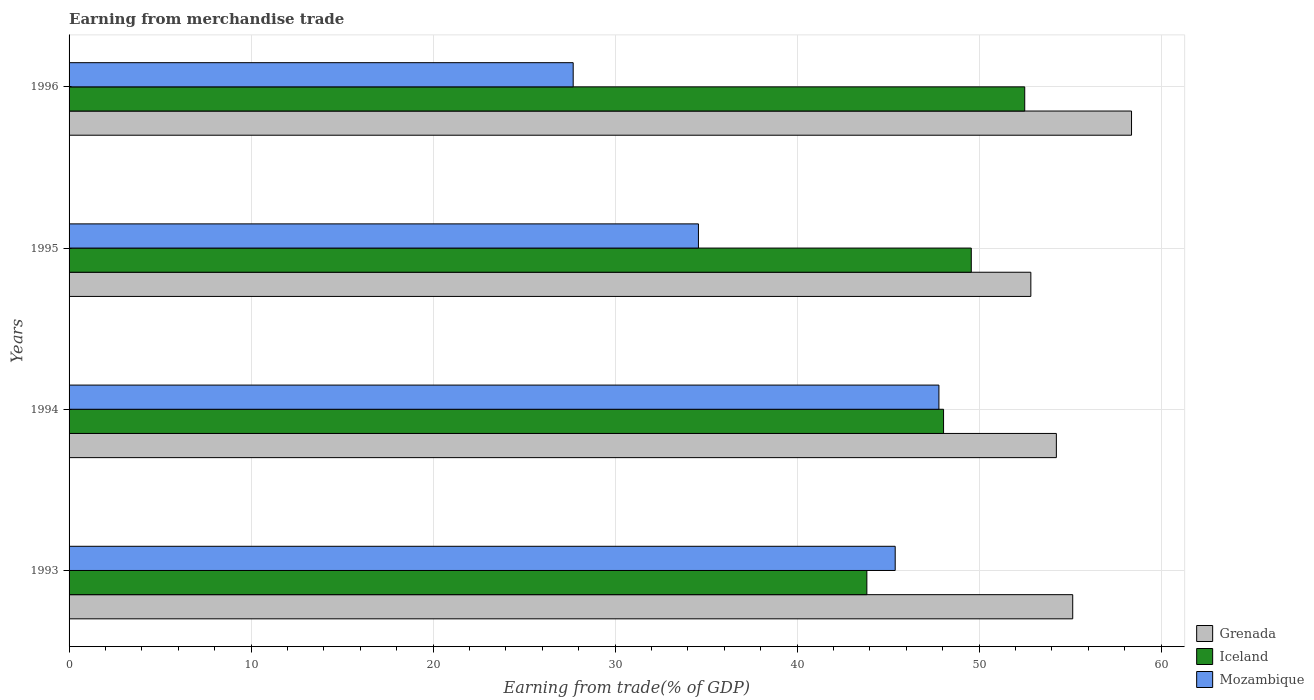How many bars are there on the 4th tick from the top?
Provide a succinct answer. 3. How many bars are there on the 4th tick from the bottom?
Make the answer very short. 3. What is the label of the 3rd group of bars from the top?
Keep it short and to the point. 1994. What is the earnings from trade in Grenada in 1995?
Your response must be concise. 52.84. Across all years, what is the maximum earnings from trade in Iceland?
Your response must be concise. 52.51. Across all years, what is the minimum earnings from trade in Grenada?
Keep it short and to the point. 52.84. In which year was the earnings from trade in Iceland minimum?
Make the answer very short. 1993. What is the total earnings from trade in Iceland in the graph?
Ensure brevity in your answer.  193.96. What is the difference between the earnings from trade in Mozambique in 1993 and that in 1996?
Your answer should be very brief. 17.69. What is the difference between the earnings from trade in Mozambique in 1994 and the earnings from trade in Iceland in 1995?
Your answer should be very brief. -1.78. What is the average earnings from trade in Iceland per year?
Keep it short and to the point. 48.49. In the year 1995, what is the difference between the earnings from trade in Iceland and earnings from trade in Grenada?
Provide a succinct answer. -3.27. What is the ratio of the earnings from trade in Mozambique in 1994 to that in 1995?
Make the answer very short. 1.38. Is the earnings from trade in Grenada in 1993 less than that in 1996?
Ensure brevity in your answer.  Yes. What is the difference between the highest and the second highest earnings from trade in Mozambique?
Keep it short and to the point. 2.4. What is the difference between the highest and the lowest earnings from trade in Iceland?
Offer a very short reply. 8.67. In how many years, is the earnings from trade in Grenada greater than the average earnings from trade in Grenada taken over all years?
Provide a short and direct response. 1. Is the sum of the earnings from trade in Mozambique in 1993 and 1996 greater than the maximum earnings from trade in Iceland across all years?
Ensure brevity in your answer.  Yes. What does the 3rd bar from the top in 1995 represents?
Ensure brevity in your answer.  Grenada. What does the 3rd bar from the bottom in 1996 represents?
Offer a terse response. Mozambique. Is it the case that in every year, the sum of the earnings from trade in Grenada and earnings from trade in Mozambique is greater than the earnings from trade in Iceland?
Provide a succinct answer. Yes. Are all the bars in the graph horizontal?
Ensure brevity in your answer.  Yes. What is the difference between two consecutive major ticks on the X-axis?
Offer a terse response. 10. Are the values on the major ticks of X-axis written in scientific E-notation?
Offer a very short reply. No. Where does the legend appear in the graph?
Your answer should be compact. Bottom right. How are the legend labels stacked?
Provide a short and direct response. Vertical. What is the title of the graph?
Ensure brevity in your answer.  Earning from merchandise trade. What is the label or title of the X-axis?
Ensure brevity in your answer.  Earning from trade(% of GDP). What is the Earning from trade(% of GDP) of Grenada in 1993?
Your response must be concise. 55.14. What is the Earning from trade(% of GDP) in Iceland in 1993?
Your answer should be very brief. 43.83. What is the Earning from trade(% of GDP) in Mozambique in 1993?
Your answer should be compact. 45.39. What is the Earning from trade(% of GDP) of Grenada in 1994?
Provide a succinct answer. 54.24. What is the Earning from trade(% of GDP) of Iceland in 1994?
Offer a very short reply. 48.05. What is the Earning from trade(% of GDP) of Mozambique in 1994?
Offer a terse response. 47.79. What is the Earning from trade(% of GDP) of Grenada in 1995?
Provide a short and direct response. 52.84. What is the Earning from trade(% of GDP) of Iceland in 1995?
Make the answer very short. 49.57. What is the Earning from trade(% of GDP) of Mozambique in 1995?
Make the answer very short. 34.58. What is the Earning from trade(% of GDP) in Grenada in 1996?
Keep it short and to the point. 58.37. What is the Earning from trade(% of GDP) in Iceland in 1996?
Offer a terse response. 52.51. What is the Earning from trade(% of GDP) in Mozambique in 1996?
Your answer should be very brief. 27.7. Across all years, what is the maximum Earning from trade(% of GDP) of Grenada?
Keep it short and to the point. 58.37. Across all years, what is the maximum Earning from trade(% of GDP) in Iceland?
Offer a very short reply. 52.51. Across all years, what is the maximum Earning from trade(% of GDP) in Mozambique?
Offer a very short reply. 47.79. Across all years, what is the minimum Earning from trade(% of GDP) of Grenada?
Provide a short and direct response. 52.84. Across all years, what is the minimum Earning from trade(% of GDP) in Iceland?
Provide a succinct answer. 43.83. Across all years, what is the minimum Earning from trade(% of GDP) of Mozambique?
Offer a very short reply. 27.7. What is the total Earning from trade(% of GDP) in Grenada in the graph?
Provide a succinct answer. 220.6. What is the total Earning from trade(% of GDP) of Iceland in the graph?
Your response must be concise. 193.96. What is the total Earning from trade(% of GDP) in Mozambique in the graph?
Make the answer very short. 155.46. What is the difference between the Earning from trade(% of GDP) in Grenada in 1993 and that in 1994?
Offer a very short reply. 0.9. What is the difference between the Earning from trade(% of GDP) of Iceland in 1993 and that in 1994?
Provide a short and direct response. -4.21. What is the difference between the Earning from trade(% of GDP) of Mozambique in 1993 and that in 1994?
Your answer should be compact. -2.4. What is the difference between the Earning from trade(% of GDP) in Grenada in 1993 and that in 1995?
Ensure brevity in your answer.  2.3. What is the difference between the Earning from trade(% of GDP) of Iceland in 1993 and that in 1995?
Provide a succinct answer. -5.74. What is the difference between the Earning from trade(% of GDP) of Mozambique in 1993 and that in 1995?
Ensure brevity in your answer.  10.81. What is the difference between the Earning from trade(% of GDP) of Grenada in 1993 and that in 1996?
Your answer should be very brief. -3.23. What is the difference between the Earning from trade(% of GDP) in Iceland in 1993 and that in 1996?
Give a very brief answer. -8.67. What is the difference between the Earning from trade(% of GDP) in Mozambique in 1993 and that in 1996?
Make the answer very short. 17.69. What is the difference between the Earning from trade(% of GDP) in Grenada in 1994 and that in 1995?
Provide a succinct answer. 1.4. What is the difference between the Earning from trade(% of GDP) in Iceland in 1994 and that in 1995?
Offer a very short reply. -1.52. What is the difference between the Earning from trade(% of GDP) in Mozambique in 1994 and that in 1995?
Offer a very short reply. 13.21. What is the difference between the Earning from trade(% of GDP) of Grenada in 1994 and that in 1996?
Your response must be concise. -4.13. What is the difference between the Earning from trade(% of GDP) in Iceland in 1994 and that in 1996?
Your response must be concise. -4.46. What is the difference between the Earning from trade(% of GDP) in Mozambique in 1994 and that in 1996?
Keep it short and to the point. 20.09. What is the difference between the Earning from trade(% of GDP) of Grenada in 1995 and that in 1996?
Offer a very short reply. -5.53. What is the difference between the Earning from trade(% of GDP) in Iceland in 1995 and that in 1996?
Keep it short and to the point. -2.94. What is the difference between the Earning from trade(% of GDP) of Mozambique in 1995 and that in 1996?
Ensure brevity in your answer.  6.88. What is the difference between the Earning from trade(% of GDP) of Grenada in 1993 and the Earning from trade(% of GDP) of Iceland in 1994?
Ensure brevity in your answer.  7.1. What is the difference between the Earning from trade(% of GDP) of Grenada in 1993 and the Earning from trade(% of GDP) of Mozambique in 1994?
Ensure brevity in your answer.  7.35. What is the difference between the Earning from trade(% of GDP) in Iceland in 1993 and the Earning from trade(% of GDP) in Mozambique in 1994?
Your answer should be very brief. -3.96. What is the difference between the Earning from trade(% of GDP) in Grenada in 1993 and the Earning from trade(% of GDP) in Iceland in 1995?
Your answer should be compact. 5.57. What is the difference between the Earning from trade(% of GDP) of Grenada in 1993 and the Earning from trade(% of GDP) of Mozambique in 1995?
Ensure brevity in your answer.  20.56. What is the difference between the Earning from trade(% of GDP) of Iceland in 1993 and the Earning from trade(% of GDP) of Mozambique in 1995?
Provide a short and direct response. 9.25. What is the difference between the Earning from trade(% of GDP) in Grenada in 1993 and the Earning from trade(% of GDP) in Iceland in 1996?
Provide a short and direct response. 2.64. What is the difference between the Earning from trade(% of GDP) in Grenada in 1993 and the Earning from trade(% of GDP) in Mozambique in 1996?
Make the answer very short. 27.45. What is the difference between the Earning from trade(% of GDP) of Iceland in 1993 and the Earning from trade(% of GDP) of Mozambique in 1996?
Offer a terse response. 16.14. What is the difference between the Earning from trade(% of GDP) of Grenada in 1994 and the Earning from trade(% of GDP) of Iceland in 1995?
Ensure brevity in your answer.  4.67. What is the difference between the Earning from trade(% of GDP) of Grenada in 1994 and the Earning from trade(% of GDP) of Mozambique in 1995?
Offer a terse response. 19.67. What is the difference between the Earning from trade(% of GDP) in Iceland in 1994 and the Earning from trade(% of GDP) in Mozambique in 1995?
Your answer should be compact. 13.47. What is the difference between the Earning from trade(% of GDP) in Grenada in 1994 and the Earning from trade(% of GDP) in Iceland in 1996?
Provide a short and direct response. 1.74. What is the difference between the Earning from trade(% of GDP) in Grenada in 1994 and the Earning from trade(% of GDP) in Mozambique in 1996?
Keep it short and to the point. 26.55. What is the difference between the Earning from trade(% of GDP) in Iceland in 1994 and the Earning from trade(% of GDP) in Mozambique in 1996?
Your answer should be compact. 20.35. What is the difference between the Earning from trade(% of GDP) in Grenada in 1995 and the Earning from trade(% of GDP) in Iceland in 1996?
Offer a terse response. 0.34. What is the difference between the Earning from trade(% of GDP) in Grenada in 1995 and the Earning from trade(% of GDP) in Mozambique in 1996?
Provide a succinct answer. 25.14. What is the difference between the Earning from trade(% of GDP) of Iceland in 1995 and the Earning from trade(% of GDP) of Mozambique in 1996?
Offer a very short reply. 21.87. What is the average Earning from trade(% of GDP) in Grenada per year?
Offer a terse response. 55.15. What is the average Earning from trade(% of GDP) of Iceland per year?
Your answer should be very brief. 48.49. What is the average Earning from trade(% of GDP) of Mozambique per year?
Your answer should be compact. 38.86. In the year 1993, what is the difference between the Earning from trade(% of GDP) of Grenada and Earning from trade(% of GDP) of Iceland?
Offer a very short reply. 11.31. In the year 1993, what is the difference between the Earning from trade(% of GDP) in Grenada and Earning from trade(% of GDP) in Mozambique?
Make the answer very short. 9.75. In the year 1993, what is the difference between the Earning from trade(% of GDP) of Iceland and Earning from trade(% of GDP) of Mozambique?
Provide a short and direct response. -1.56. In the year 1994, what is the difference between the Earning from trade(% of GDP) in Grenada and Earning from trade(% of GDP) in Iceland?
Provide a succinct answer. 6.2. In the year 1994, what is the difference between the Earning from trade(% of GDP) of Grenada and Earning from trade(% of GDP) of Mozambique?
Your answer should be compact. 6.45. In the year 1994, what is the difference between the Earning from trade(% of GDP) of Iceland and Earning from trade(% of GDP) of Mozambique?
Your answer should be very brief. 0.26. In the year 1995, what is the difference between the Earning from trade(% of GDP) of Grenada and Earning from trade(% of GDP) of Iceland?
Keep it short and to the point. 3.27. In the year 1995, what is the difference between the Earning from trade(% of GDP) in Grenada and Earning from trade(% of GDP) in Mozambique?
Ensure brevity in your answer.  18.26. In the year 1995, what is the difference between the Earning from trade(% of GDP) in Iceland and Earning from trade(% of GDP) in Mozambique?
Ensure brevity in your answer.  14.99. In the year 1996, what is the difference between the Earning from trade(% of GDP) in Grenada and Earning from trade(% of GDP) in Iceland?
Make the answer very short. 5.87. In the year 1996, what is the difference between the Earning from trade(% of GDP) of Grenada and Earning from trade(% of GDP) of Mozambique?
Give a very brief answer. 30.68. In the year 1996, what is the difference between the Earning from trade(% of GDP) of Iceland and Earning from trade(% of GDP) of Mozambique?
Ensure brevity in your answer.  24.81. What is the ratio of the Earning from trade(% of GDP) in Grenada in 1993 to that in 1994?
Your answer should be compact. 1.02. What is the ratio of the Earning from trade(% of GDP) of Iceland in 1993 to that in 1994?
Keep it short and to the point. 0.91. What is the ratio of the Earning from trade(% of GDP) of Mozambique in 1993 to that in 1994?
Make the answer very short. 0.95. What is the ratio of the Earning from trade(% of GDP) in Grenada in 1993 to that in 1995?
Ensure brevity in your answer.  1.04. What is the ratio of the Earning from trade(% of GDP) in Iceland in 1993 to that in 1995?
Ensure brevity in your answer.  0.88. What is the ratio of the Earning from trade(% of GDP) of Mozambique in 1993 to that in 1995?
Your answer should be compact. 1.31. What is the ratio of the Earning from trade(% of GDP) of Grenada in 1993 to that in 1996?
Keep it short and to the point. 0.94. What is the ratio of the Earning from trade(% of GDP) of Iceland in 1993 to that in 1996?
Provide a succinct answer. 0.83. What is the ratio of the Earning from trade(% of GDP) in Mozambique in 1993 to that in 1996?
Provide a succinct answer. 1.64. What is the ratio of the Earning from trade(% of GDP) of Grenada in 1994 to that in 1995?
Keep it short and to the point. 1.03. What is the ratio of the Earning from trade(% of GDP) of Iceland in 1994 to that in 1995?
Your answer should be very brief. 0.97. What is the ratio of the Earning from trade(% of GDP) in Mozambique in 1994 to that in 1995?
Make the answer very short. 1.38. What is the ratio of the Earning from trade(% of GDP) of Grenada in 1994 to that in 1996?
Provide a short and direct response. 0.93. What is the ratio of the Earning from trade(% of GDP) in Iceland in 1994 to that in 1996?
Provide a short and direct response. 0.92. What is the ratio of the Earning from trade(% of GDP) in Mozambique in 1994 to that in 1996?
Your response must be concise. 1.73. What is the ratio of the Earning from trade(% of GDP) of Grenada in 1995 to that in 1996?
Your response must be concise. 0.91. What is the ratio of the Earning from trade(% of GDP) of Iceland in 1995 to that in 1996?
Keep it short and to the point. 0.94. What is the ratio of the Earning from trade(% of GDP) in Mozambique in 1995 to that in 1996?
Offer a very short reply. 1.25. What is the difference between the highest and the second highest Earning from trade(% of GDP) of Grenada?
Your answer should be very brief. 3.23. What is the difference between the highest and the second highest Earning from trade(% of GDP) in Iceland?
Keep it short and to the point. 2.94. What is the difference between the highest and the second highest Earning from trade(% of GDP) in Mozambique?
Offer a terse response. 2.4. What is the difference between the highest and the lowest Earning from trade(% of GDP) in Grenada?
Your answer should be very brief. 5.53. What is the difference between the highest and the lowest Earning from trade(% of GDP) of Iceland?
Your response must be concise. 8.67. What is the difference between the highest and the lowest Earning from trade(% of GDP) in Mozambique?
Give a very brief answer. 20.09. 